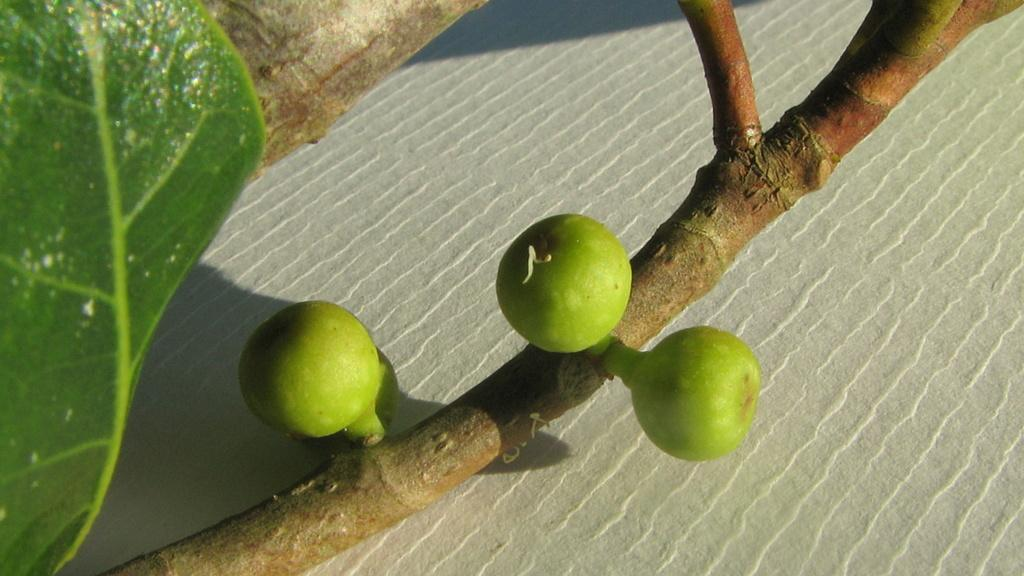What is present on the tree branch in the image? There is a leaf and fruits on the tree branch in the image. Can you describe the leaf on the tree branch? The leaf on the tree branch is green and appears to be healthy. What type of fruits are on the tree branch? The fruits on the tree branch are not specified in the image. What advertisement can be seen on the tree branch in the image? There is no advertisement present on the tree branch in the image. How many ladybugs are on the tree branch in the image? There are no ladybugs present on the tree branch in the image. 